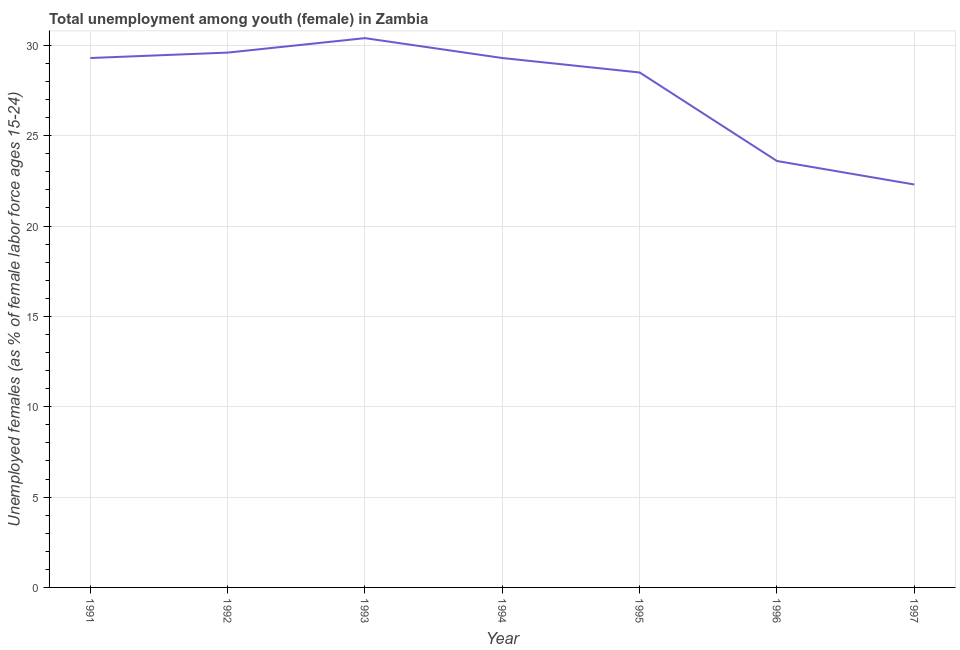What is the unemployed female youth population in 1993?
Provide a succinct answer. 30.4. Across all years, what is the maximum unemployed female youth population?
Your response must be concise. 30.4. Across all years, what is the minimum unemployed female youth population?
Your answer should be compact. 22.3. In which year was the unemployed female youth population maximum?
Your response must be concise. 1993. What is the sum of the unemployed female youth population?
Ensure brevity in your answer.  193. What is the difference between the unemployed female youth population in 1992 and 1996?
Provide a short and direct response. 6. What is the average unemployed female youth population per year?
Make the answer very short. 27.57. What is the median unemployed female youth population?
Ensure brevity in your answer.  29.3. In how many years, is the unemployed female youth population greater than 20 %?
Offer a terse response. 7. Do a majority of the years between 1996 and 1991 (inclusive) have unemployed female youth population greater than 11 %?
Your answer should be very brief. Yes. What is the ratio of the unemployed female youth population in 1992 to that in 1996?
Offer a very short reply. 1.25. Is the unemployed female youth population in 1991 less than that in 1996?
Your response must be concise. No. What is the difference between the highest and the second highest unemployed female youth population?
Make the answer very short. 0.8. Is the sum of the unemployed female youth population in 1992 and 1995 greater than the maximum unemployed female youth population across all years?
Give a very brief answer. Yes. What is the difference between the highest and the lowest unemployed female youth population?
Provide a succinct answer. 8.1. In how many years, is the unemployed female youth population greater than the average unemployed female youth population taken over all years?
Offer a very short reply. 5. Does the unemployed female youth population monotonically increase over the years?
Provide a short and direct response. No. How many lines are there?
Provide a succinct answer. 1. Does the graph contain grids?
Provide a short and direct response. Yes. What is the title of the graph?
Provide a short and direct response. Total unemployment among youth (female) in Zambia. What is the label or title of the X-axis?
Give a very brief answer. Year. What is the label or title of the Y-axis?
Provide a succinct answer. Unemployed females (as % of female labor force ages 15-24). What is the Unemployed females (as % of female labor force ages 15-24) in 1991?
Your response must be concise. 29.3. What is the Unemployed females (as % of female labor force ages 15-24) of 1992?
Your answer should be compact. 29.6. What is the Unemployed females (as % of female labor force ages 15-24) in 1993?
Provide a short and direct response. 30.4. What is the Unemployed females (as % of female labor force ages 15-24) of 1994?
Make the answer very short. 29.3. What is the Unemployed females (as % of female labor force ages 15-24) of 1995?
Make the answer very short. 28.5. What is the Unemployed females (as % of female labor force ages 15-24) in 1996?
Your answer should be very brief. 23.6. What is the Unemployed females (as % of female labor force ages 15-24) in 1997?
Give a very brief answer. 22.3. What is the difference between the Unemployed females (as % of female labor force ages 15-24) in 1991 and 1992?
Offer a terse response. -0.3. What is the difference between the Unemployed females (as % of female labor force ages 15-24) in 1991 and 1995?
Your response must be concise. 0.8. What is the difference between the Unemployed females (as % of female labor force ages 15-24) in 1991 and 1996?
Give a very brief answer. 5.7. What is the difference between the Unemployed females (as % of female labor force ages 15-24) in 1991 and 1997?
Provide a short and direct response. 7. What is the difference between the Unemployed females (as % of female labor force ages 15-24) in 1992 and 1993?
Your answer should be compact. -0.8. What is the difference between the Unemployed females (as % of female labor force ages 15-24) in 1992 and 1995?
Ensure brevity in your answer.  1.1. What is the difference between the Unemployed females (as % of female labor force ages 15-24) in 1992 and 1996?
Keep it short and to the point. 6. What is the difference between the Unemployed females (as % of female labor force ages 15-24) in 1992 and 1997?
Make the answer very short. 7.3. What is the difference between the Unemployed females (as % of female labor force ages 15-24) in 1993 and 1994?
Give a very brief answer. 1.1. What is the difference between the Unemployed females (as % of female labor force ages 15-24) in 1993 and 1997?
Your answer should be compact. 8.1. What is the difference between the Unemployed females (as % of female labor force ages 15-24) in 1994 and 1995?
Your response must be concise. 0.8. What is the difference between the Unemployed females (as % of female labor force ages 15-24) in 1994 and 1997?
Your answer should be compact. 7. What is the difference between the Unemployed females (as % of female labor force ages 15-24) in 1995 and 1997?
Provide a succinct answer. 6.2. What is the ratio of the Unemployed females (as % of female labor force ages 15-24) in 1991 to that in 1992?
Offer a very short reply. 0.99. What is the ratio of the Unemployed females (as % of female labor force ages 15-24) in 1991 to that in 1995?
Your response must be concise. 1.03. What is the ratio of the Unemployed females (as % of female labor force ages 15-24) in 1991 to that in 1996?
Make the answer very short. 1.24. What is the ratio of the Unemployed females (as % of female labor force ages 15-24) in 1991 to that in 1997?
Keep it short and to the point. 1.31. What is the ratio of the Unemployed females (as % of female labor force ages 15-24) in 1992 to that in 1993?
Your answer should be very brief. 0.97. What is the ratio of the Unemployed females (as % of female labor force ages 15-24) in 1992 to that in 1994?
Offer a very short reply. 1.01. What is the ratio of the Unemployed females (as % of female labor force ages 15-24) in 1992 to that in 1995?
Keep it short and to the point. 1.04. What is the ratio of the Unemployed females (as % of female labor force ages 15-24) in 1992 to that in 1996?
Offer a very short reply. 1.25. What is the ratio of the Unemployed females (as % of female labor force ages 15-24) in 1992 to that in 1997?
Keep it short and to the point. 1.33. What is the ratio of the Unemployed females (as % of female labor force ages 15-24) in 1993 to that in 1994?
Provide a short and direct response. 1.04. What is the ratio of the Unemployed females (as % of female labor force ages 15-24) in 1993 to that in 1995?
Your answer should be compact. 1.07. What is the ratio of the Unemployed females (as % of female labor force ages 15-24) in 1993 to that in 1996?
Provide a short and direct response. 1.29. What is the ratio of the Unemployed females (as % of female labor force ages 15-24) in 1993 to that in 1997?
Make the answer very short. 1.36. What is the ratio of the Unemployed females (as % of female labor force ages 15-24) in 1994 to that in 1995?
Ensure brevity in your answer.  1.03. What is the ratio of the Unemployed females (as % of female labor force ages 15-24) in 1994 to that in 1996?
Offer a terse response. 1.24. What is the ratio of the Unemployed females (as % of female labor force ages 15-24) in 1994 to that in 1997?
Offer a terse response. 1.31. What is the ratio of the Unemployed females (as % of female labor force ages 15-24) in 1995 to that in 1996?
Your answer should be very brief. 1.21. What is the ratio of the Unemployed females (as % of female labor force ages 15-24) in 1995 to that in 1997?
Make the answer very short. 1.28. What is the ratio of the Unemployed females (as % of female labor force ages 15-24) in 1996 to that in 1997?
Provide a succinct answer. 1.06. 